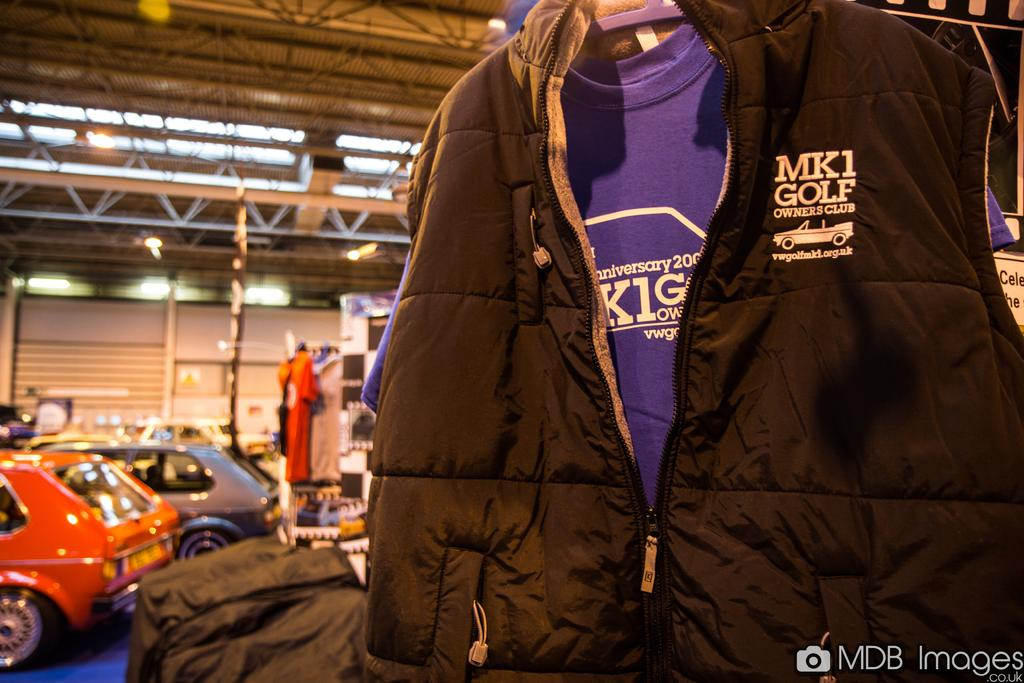What type of clothing item is visible in the image? There is a jacket in the image. What else can be seen in the image besides the jacket? There are cars, lights, and poles visible in the image. What is the background of the image? There is a wall in the background of the image. How does the coal contribute to the lighting in the image? There is no coal present in the image, so it cannot contribute to the lighting. 